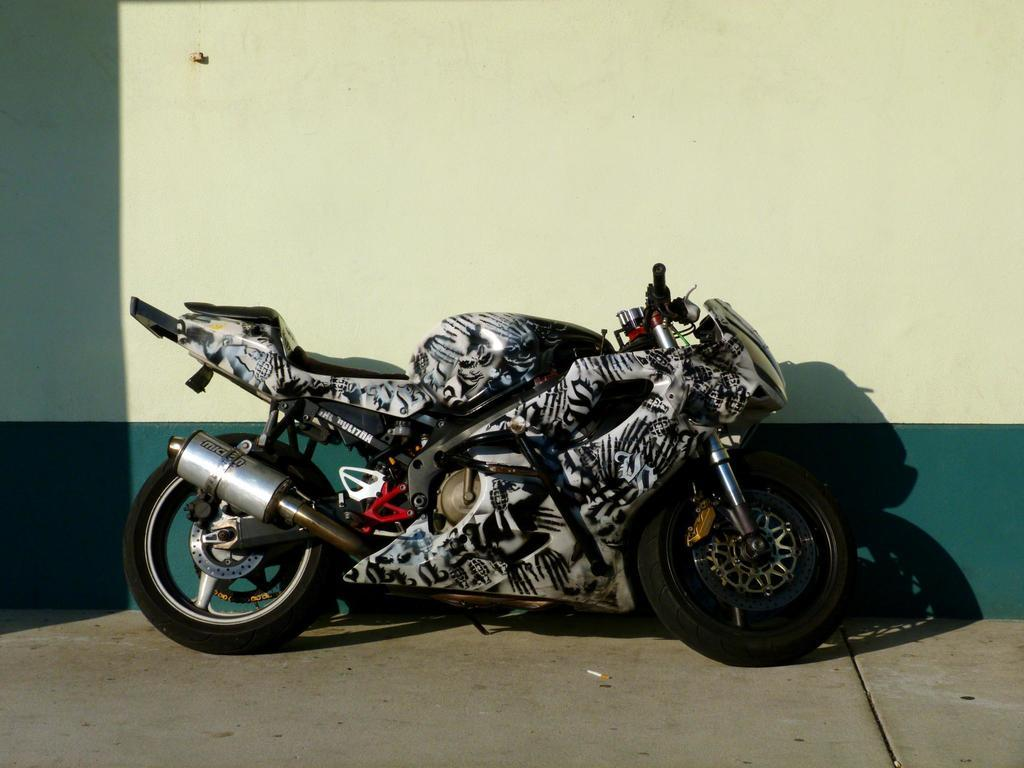What type of bike is featured in the image? There is a racing bike in the image. Where is the racing bike located in relation to other objects? The racing bike is kept in front of a wall. How does the racing bike help the person breathe better in the image? The racing bike does not have any direct impact on the person's breathing in the image. 